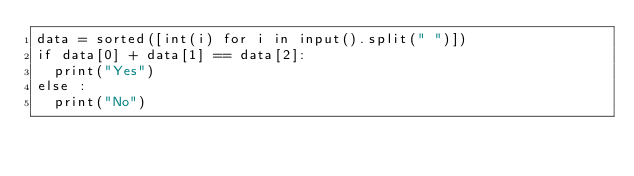<code> <loc_0><loc_0><loc_500><loc_500><_Python_>data = sorted([int(i) for i in input().split(" ")])
if data[0] + data[1] == data[2]:
  print("Yes")
else :
  print("No")</code> 